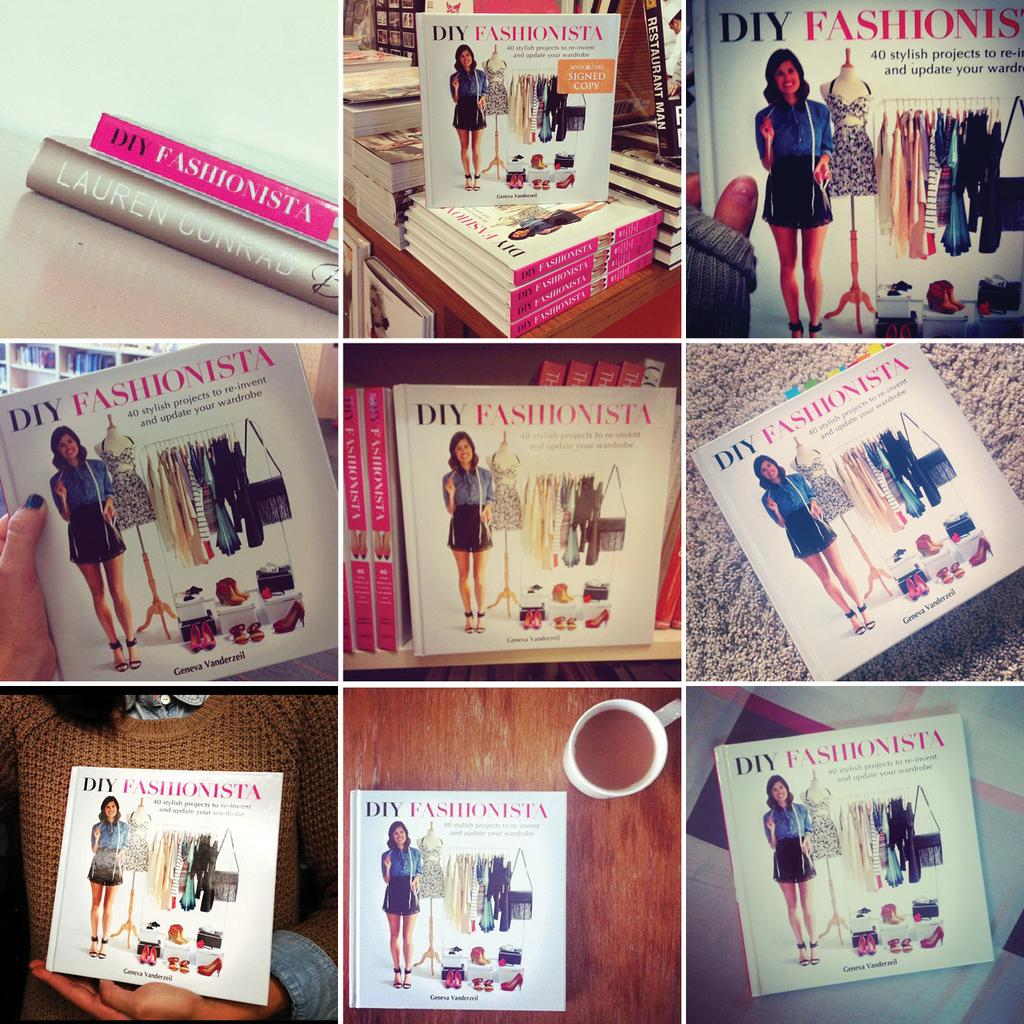Provide a one-sentence caption for the provided image. A fashion themed book is seen in 9 different angles. 